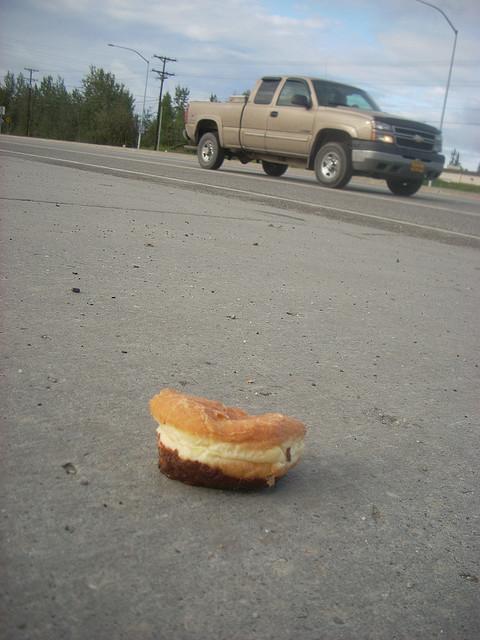What color is the truck?
Be succinct. Tan. What is laying in the street?
Keep it brief. Sandwich. Why is the burger lying on the street?
Answer briefly. Dropped. Are there clouds?
Answer briefly. Yes. 